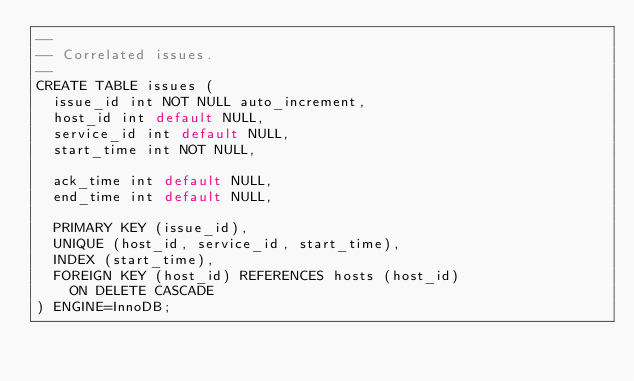Convert code to text. <code><loc_0><loc_0><loc_500><loc_500><_SQL_>--
-- Correlated issues.
--
CREATE TABLE issues (
  issue_id int NOT NULL auto_increment,
  host_id int default NULL,
  service_id int default NULL,
  start_time int NOT NULL,

  ack_time int default NULL,
  end_time int default NULL,

  PRIMARY KEY (issue_id),
  UNIQUE (host_id, service_id, start_time),
  INDEX (start_time),
  FOREIGN KEY (host_id) REFERENCES hosts (host_id)
    ON DELETE CASCADE
) ENGINE=InnoDB;
</code> 